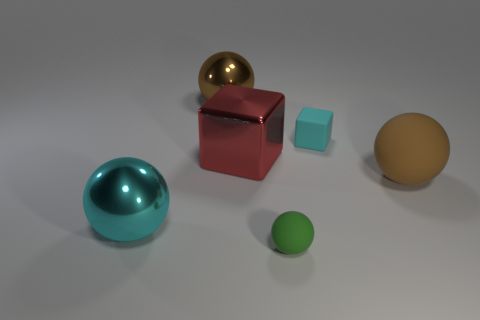Subtract all tiny green balls. How many balls are left? 3 Subtract all gray cylinders. How many brown balls are left? 2 Subtract all green balls. How many balls are left? 3 Add 2 tiny spheres. How many objects exist? 8 Subtract all spheres. How many objects are left? 2 Subtract 0 purple spheres. How many objects are left? 6 Subtract all blue balls. Subtract all cyan cubes. How many balls are left? 4 Subtract all tiny gray balls. Subtract all brown objects. How many objects are left? 4 Add 6 large objects. How many large objects are left? 10 Add 1 small blue metal cylinders. How many small blue metal cylinders exist? 1 